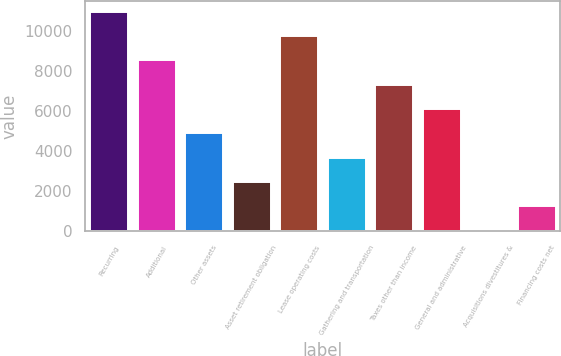Convert chart. <chart><loc_0><loc_0><loc_500><loc_500><bar_chart><fcel>Recurring<fcel>Additional<fcel>Other assets<fcel>Asset retirement obligation<fcel>Lease operating costs<fcel>Gathering and transportation<fcel>Taxes other than income<fcel>General and administrative<fcel>Acquisitions divestitures &<fcel>Financing costs net<nl><fcel>10984<fcel>8550<fcel>4899<fcel>2465<fcel>9767<fcel>3682<fcel>7333<fcel>6116<fcel>31<fcel>1248<nl></chart> 